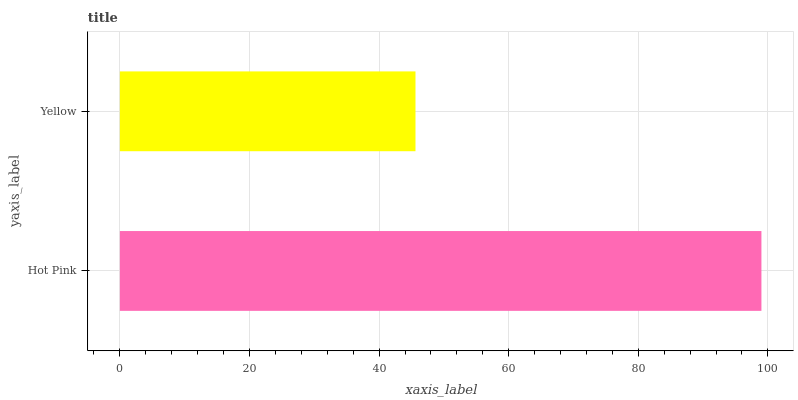Is Yellow the minimum?
Answer yes or no. Yes. Is Hot Pink the maximum?
Answer yes or no. Yes. Is Yellow the maximum?
Answer yes or no. No. Is Hot Pink greater than Yellow?
Answer yes or no. Yes. Is Yellow less than Hot Pink?
Answer yes or no. Yes. Is Yellow greater than Hot Pink?
Answer yes or no. No. Is Hot Pink less than Yellow?
Answer yes or no. No. Is Hot Pink the high median?
Answer yes or no. Yes. Is Yellow the low median?
Answer yes or no. Yes. Is Yellow the high median?
Answer yes or no. No. Is Hot Pink the low median?
Answer yes or no. No. 